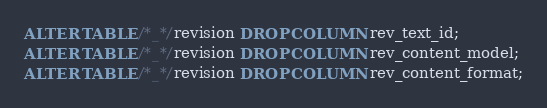Convert code to text. <code><loc_0><loc_0><loc_500><loc_500><_SQL_>ALTER TABLE /*_*/revision DROP COLUMN rev_text_id;
ALTER TABLE /*_*/revision DROP COLUMN rev_content_model;
ALTER TABLE /*_*/revision DROP COLUMN rev_content_format;
</code> 